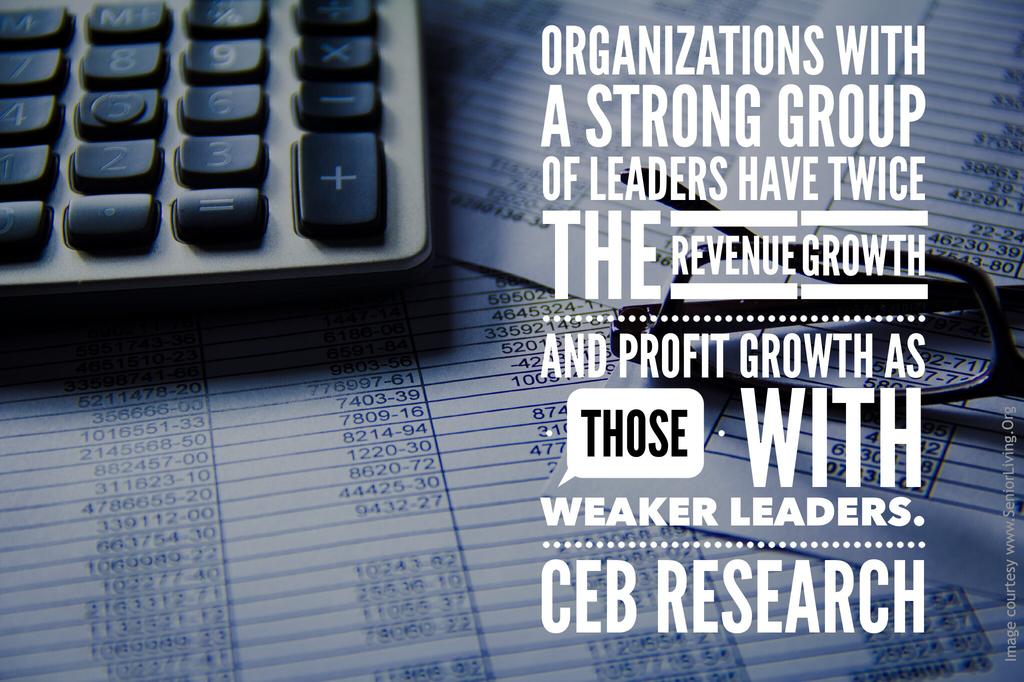Who did the research?
Provide a succinct answer. Ceb. How does the strength of leaders affect revenue growth?
Keep it short and to the point. Twice the revenue growth. 